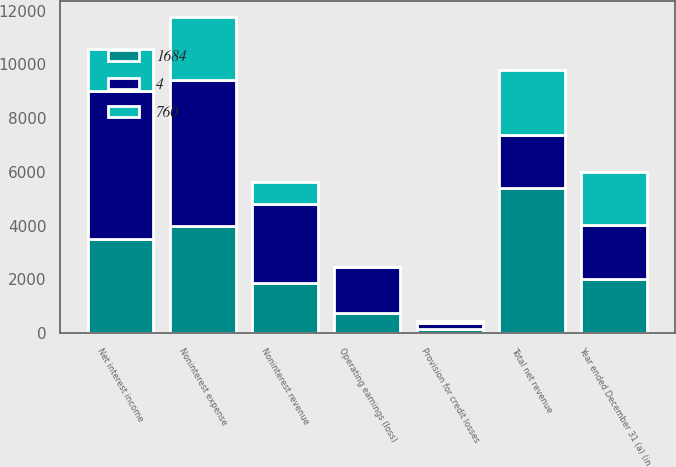Convert chart to OTSL. <chart><loc_0><loc_0><loc_500><loc_500><stacked_bar_chart><ecel><fcel>Year ended December 31 (a) (in<fcel>Noninterest revenue<fcel>Net interest income<fcel>Total net revenue<fcel>Provision for credit losses<fcel>Noninterest expense<fcel>Operating earnings (loss)<nl><fcel>4<fcel>2005<fcel>2929<fcel>5476<fcel>2003.5<fcel>214<fcel>5431<fcel>1684<nl><fcel>1684<fcel>2004<fcel>1864<fcel>3521<fcel>5385<fcel>165<fcel>3981<fcel>760<nl><fcel>760<fcel>2003<fcel>828<fcel>1594<fcel>2422<fcel>76<fcel>2358<fcel>4<nl></chart> 